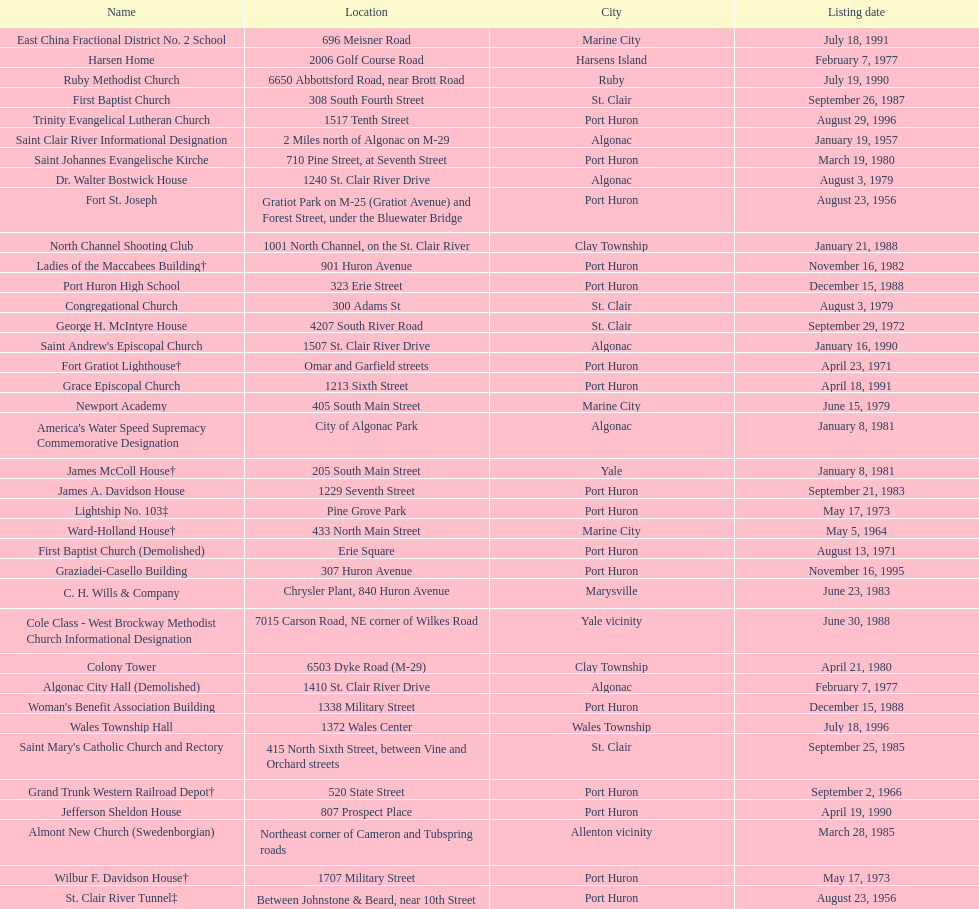What is the total number of locations in the city of algonac? 5. I'm looking to parse the entire table for insights. Could you assist me with that? {'header': ['Name', 'Location', 'City', 'Listing date'], 'rows': [['East China Fractional District No. 2 School', '696 Meisner Road', 'Marine City', 'July 18, 1991'], ['Harsen Home', '2006 Golf Course Road', 'Harsens Island', 'February 7, 1977'], ['Ruby Methodist Church', '6650 Abbottsford Road, near Brott Road', 'Ruby', 'July 19, 1990'], ['First Baptist Church', '308 South Fourth Street', 'St. Clair', 'September 26, 1987'], ['Trinity Evangelical Lutheran Church', '1517 Tenth Street', 'Port Huron', 'August 29, 1996'], ['Saint Clair River Informational Designation', '2 Miles north of Algonac on M-29', 'Algonac', 'January 19, 1957'], ['Saint Johannes Evangelische Kirche', '710 Pine Street, at Seventh Street', 'Port Huron', 'March 19, 1980'], ['Dr. Walter Bostwick House', '1240 St. Clair River Drive', 'Algonac', 'August 3, 1979'], ['Fort St. Joseph', 'Gratiot Park on M-25 (Gratiot Avenue) and Forest Street, under the Bluewater Bridge', 'Port Huron', 'August 23, 1956'], ['North Channel Shooting Club', '1001 North Channel, on the St. Clair River', 'Clay Township', 'January 21, 1988'], ['Ladies of the Maccabees Building†', '901 Huron Avenue', 'Port Huron', 'November 16, 1982'], ['Port Huron High School', '323 Erie Street', 'Port Huron', 'December 15, 1988'], ['Congregational Church', '300 Adams St', 'St. Clair', 'August 3, 1979'], ['George H. McIntyre House', '4207 South River Road', 'St. Clair', 'September 29, 1972'], ["Saint Andrew's Episcopal Church", '1507 St. Clair River Drive', 'Algonac', 'January 16, 1990'], ['Fort Gratiot Lighthouse†', 'Omar and Garfield streets', 'Port Huron', 'April 23, 1971'], ['Grace Episcopal Church', '1213 Sixth Street', 'Port Huron', 'April 18, 1991'], ['Newport Academy', '405 South Main Street', 'Marine City', 'June 15, 1979'], ["America's Water Speed Supremacy Commemorative Designation", 'City of Algonac Park', 'Algonac', 'January 8, 1981'], ['James McColl House†', '205 South Main Street', 'Yale', 'January 8, 1981'], ['James A. Davidson House', '1229 Seventh Street', 'Port Huron', 'September 21, 1983'], ['Lightship No. 103‡', 'Pine Grove Park', 'Port Huron', 'May 17, 1973'], ['Ward-Holland House†', '433 North Main Street', 'Marine City', 'May 5, 1964'], ['First Baptist Church (Demolished)', 'Erie Square', 'Port Huron', 'August 13, 1971'], ['Graziadei-Casello Building', '307 Huron Avenue', 'Port Huron', 'November 16, 1995'], ['C. H. Wills & Company', 'Chrysler Plant, 840 Huron Avenue', 'Marysville', 'June 23, 1983'], ['Cole Class - West Brockway Methodist Church Informational Designation', '7015 Carson Road, NE corner of Wilkes Road', 'Yale vicinity', 'June 30, 1988'], ['Colony Tower', '6503 Dyke Road (M-29)', 'Clay Township', 'April 21, 1980'], ['Algonac City Hall (Demolished)', '1410 St. Clair River Drive', 'Algonac', 'February 7, 1977'], ["Woman's Benefit Association Building", '1338 Military Street', 'Port Huron', 'December 15, 1988'], ['Wales Township Hall', '1372 Wales Center', 'Wales Township', 'July 18, 1996'], ["Saint Mary's Catholic Church and Rectory", '415 North Sixth Street, between Vine and Orchard streets', 'St. Clair', 'September 25, 1985'], ['Grand Trunk Western Railroad Depot†', '520 State Street', 'Port Huron', 'September 2, 1966'], ['Jefferson Sheldon House', '807 Prospect Place', 'Port Huron', 'April 19, 1990'], ['Almont New Church (Swedenborgian)', 'Northeast corner of Cameron and Tubspring roads', 'Allenton vicinity', 'March 28, 1985'], ['Wilbur F. Davidson House†', '1707 Military Street', 'Port Huron', 'May 17, 1973'], ['St. Clair River Tunnel‡', 'Between Johnstone & Beard, near 10th Street (portal site)', 'Port Huron', 'August 23, 1956'], ['Fort Sinclair (20SC58)', 'South of the mouth of the Pine River on the St. Clair River', 'St. Clair', 'February 17, 1965'], ['E. C. Williams House', '2511 Tenth Avenue, between Hancock and Church streets', 'Port Huron', 'November 18, 1993'], ['Harrington Hotel†', '1026 Military, between Pine and Wall Streets', 'Port Huron', 'November 16, 1981'], ['Marine City City Hall†', '300 Broadway Street', 'Marine City', 'August 6, 1976'], ['Gratiot Park United Methodist Church', '2503 Cherry Street', 'Port Huron', 'March 10, 1988'], ['Fort Gratiot†', '520 State Street', 'Port Huron', 'February 18, 1956'], ['Catholic Pointe', '618 South Water Street, SE corner of Bridge Street', 'Marine City', 'August 12, 1977'], ['Saint Clair Inn†', '500 Riverside', 'St. Clair', 'October 20, 1994']]} 